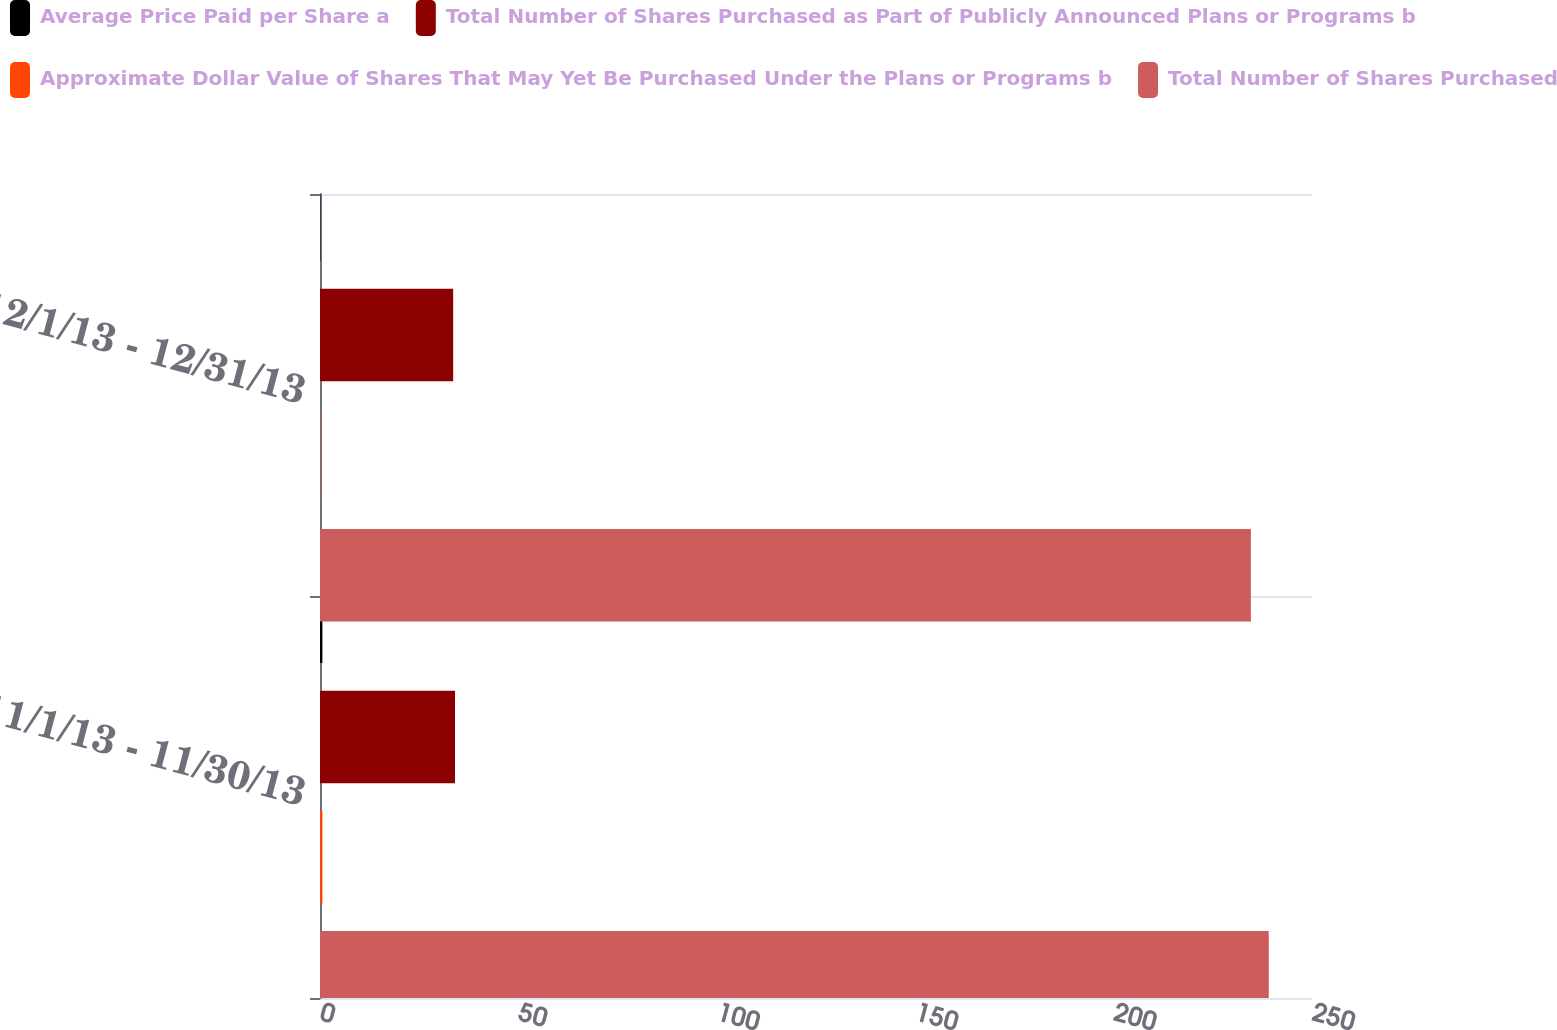Convert chart to OTSL. <chart><loc_0><loc_0><loc_500><loc_500><stacked_bar_chart><ecel><fcel>11/1/13 - 11/30/13<fcel>12/1/13 - 12/31/13<nl><fcel>Average Price Paid per Share a<fcel>0.6<fcel>0.1<nl><fcel>Total Number of Shares Purchased as Part of Publicly Announced Plans or Programs b<fcel>34.03<fcel>33.56<nl><fcel>Approximate Dollar Value of Shares That May Yet Be Purchased Under the Plans or Programs b<fcel>0.6<fcel>0.1<nl><fcel>Total Number of Shares Purchased<fcel>239.1<fcel>234.6<nl></chart> 